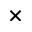<formula> <loc_0><loc_0><loc_500><loc_500>\times</formula> 